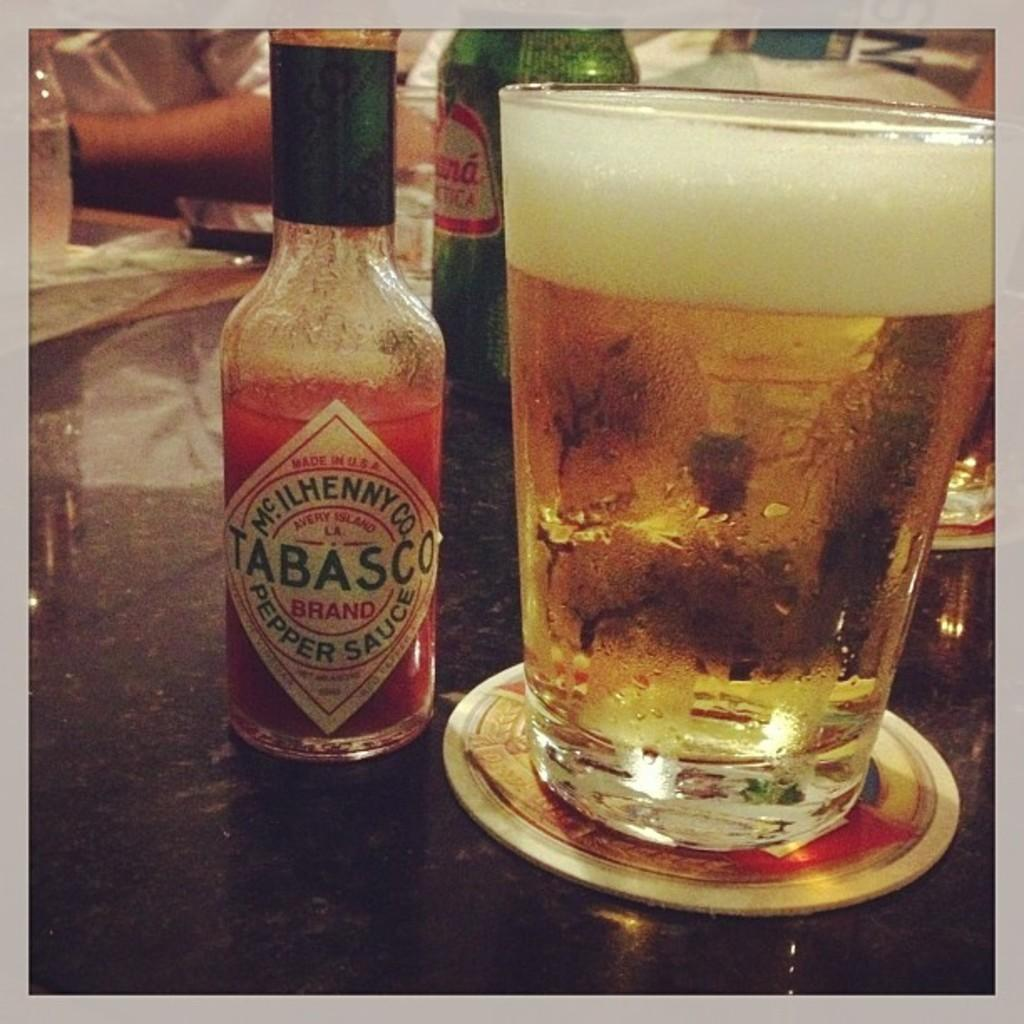<image>
Give a short and clear explanation of the subsequent image. a tabasco sauce that is next to a beer 